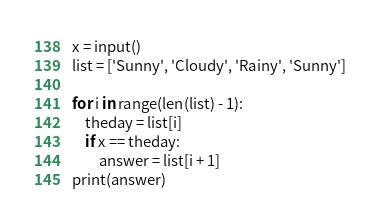<code> <loc_0><loc_0><loc_500><loc_500><_Python_>x = input()
list = ['Sunny', 'Cloudy', 'Rainy', 'Sunny']
 
for i in range(len(list) - 1):
    theday = list[i]
    if x == theday:
        answer = list[i + 1]
print(answer)</code> 